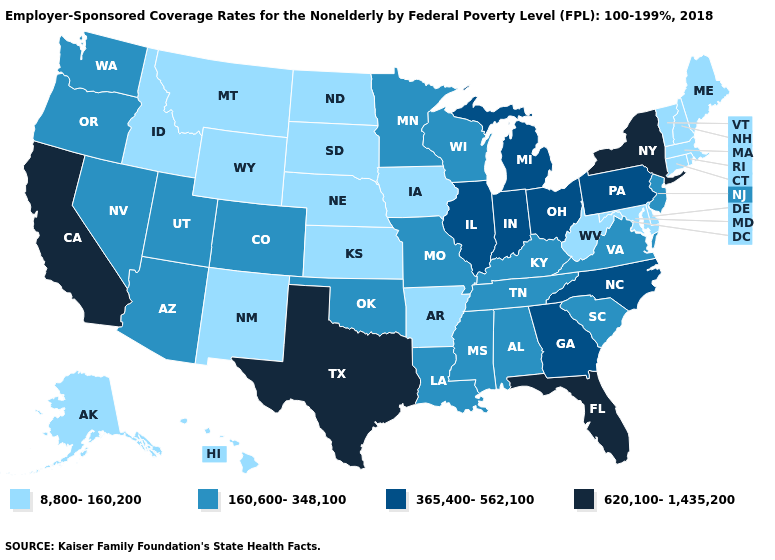What is the value of Tennessee?
Concise answer only. 160,600-348,100. What is the lowest value in states that border Florida?
Concise answer only. 160,600-348,100. What is the lowest value in the West?
Write a very short answer. 8,800-160,200. Does Kansas have the lowest value in the USA?
Write a very short answer. Yes. Which states have the lowest value in the USA?
Keep it brief. Alaska, Arkansas, Connecticut, Delaware, Hawaii, Idaho, Iowa, Kansas, Maine, Maryland, Massachusetts, Montana, Nebraska, New Hampshire, New Mexico, North Dakota, Rhode Island, South Dakota, Vermont, West Virginia, Wyoming. Does Illinois have the same value as Ohio?
Keep it brief. Yes. Does Montana have a higher value than Missouri?
Write a very short answer. No. What is the value of Nevada?
Concise answer only. 160,600-348,100. Which states have the lowest value in the Northeast?
Write a very short answer. Connecticut, Maine, Massachusetts, New Hampshire, Rhode Island, Vermont. What is the highest value in states that border Montana?
Give a very brief answer. 8,800-160,200. What is the value of New Jersey?
Write a very short answer. 160,600-348,100. What is the value of North Carolina?
Quick response, please. 365,400-562,100. Name the states that have a value in the range 365,400-562,100?
Answer briefly. Georgia, Illinois, Indiana, Michigan, North Carolina, Ohio, Pennsylvania. Does California have the highest value in the USA?
Be succinct. Yes. What is the value of Oregon?
Keep it brief. 160,600-348,100. 